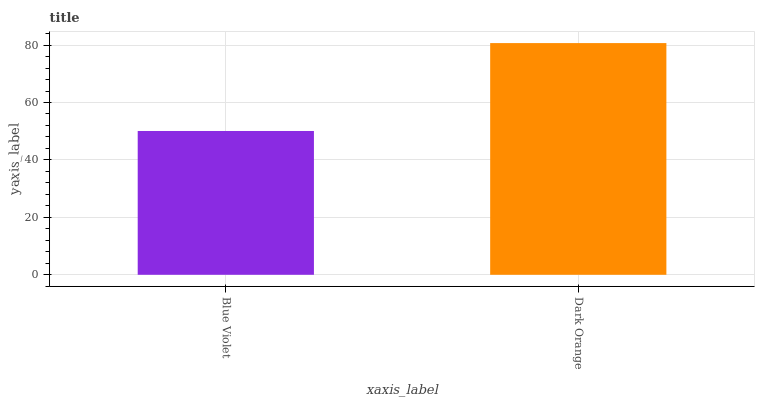Is Dark Orange the minimum?
Answer yes or no. No. Is Dark Orange greater than Blue Violet?
Answer yes or no. Yes. Is Blue Violet less than Dark Orange?
Answer yes or no. Yes. Is Blue Violet greater than Dark Orange?
Answer yes or no. No. Is Dark Orange less than Blue Violet?
Answer yes or no. No. Is Dark Orange the high median?
Answer yes or no. Yes. Is Blue Violet the low median?
Answer yes or no. Yes. Is Blue Violet the high median?
Answer yes or no. No. Is Dark Orange the low median?
Answer yes or no. No. 